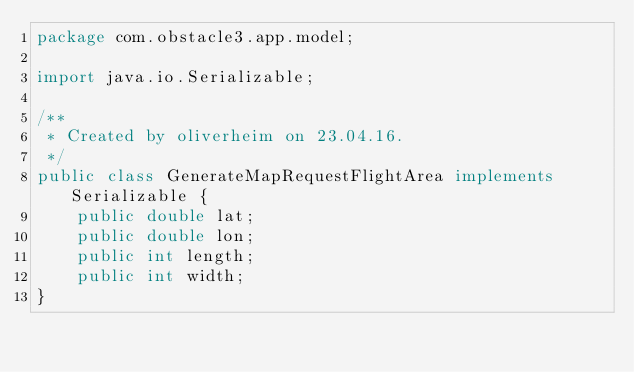Convert code to text. <code><loc_0><loc_0><loc_500><loc_500><_Java_>package com.obstacle3.app.model;

import java.io.Serializable;

/**
 * Created by oliverheim on 23.04.16.
 */
public class GenerateMapRequestFlightArea implements Serializable {
    public double lat;
    public double lon;
    public int length;
    public int width;
}
</code> 